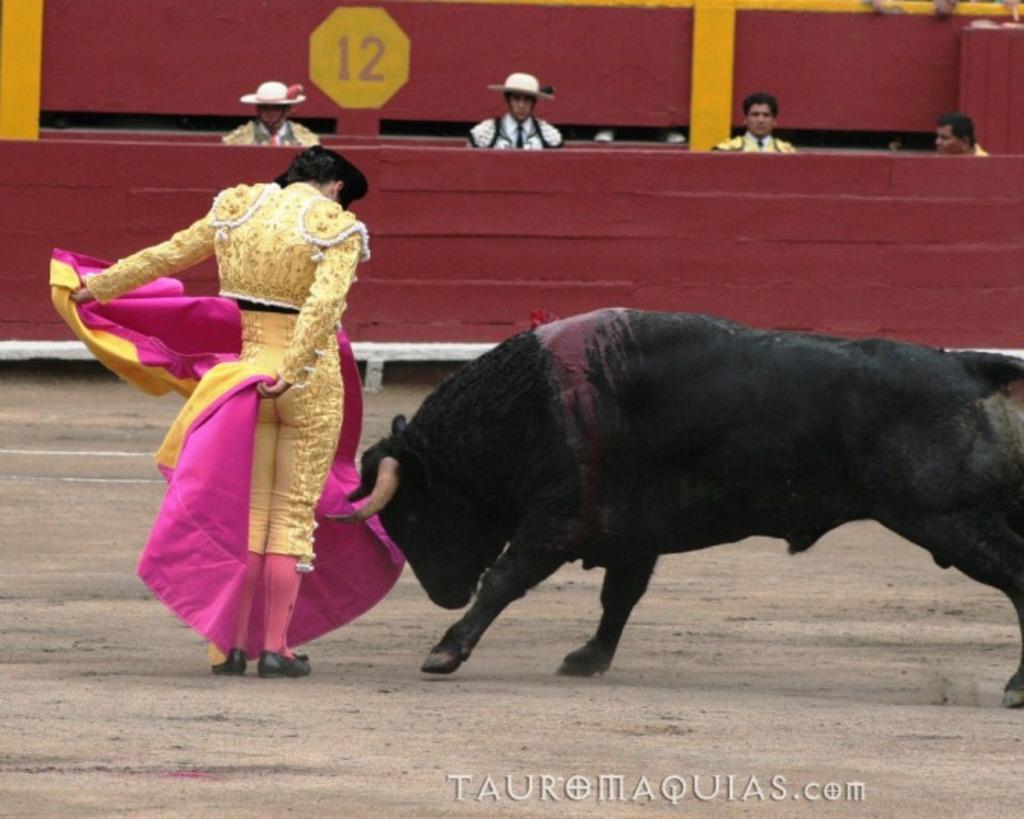In one or two sentences, can you explain what this image depicts? In this image I can see a person is standing on the left side and on the right side I can see a black colour bull. I can see this person is wearing yellow colour dress, black shoes and I can see this person is holding pink and yellow colour cloth. In the background I can see few more people and I can also see something is written in the background. On the bottom side of this image I can see a watermark. 